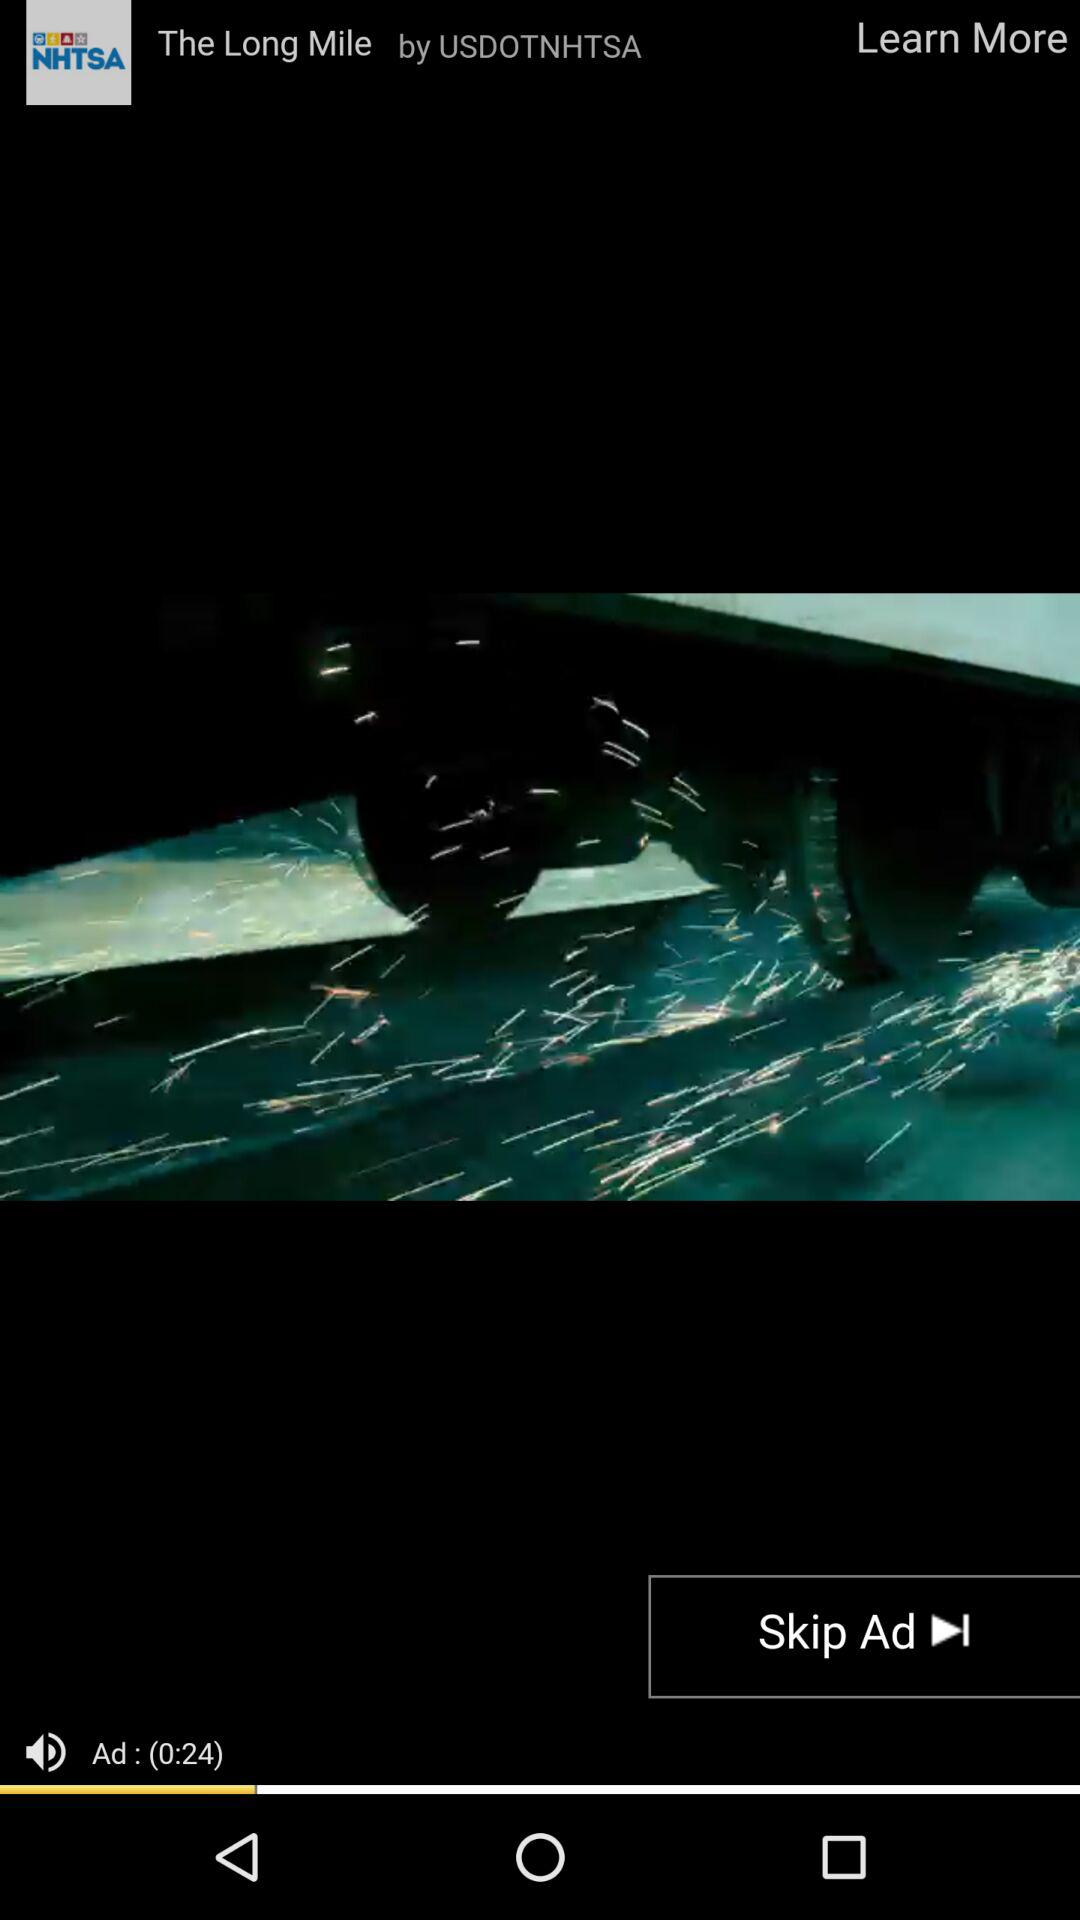How long is the video?
Answer the question using a single word or phrase. 0:24 